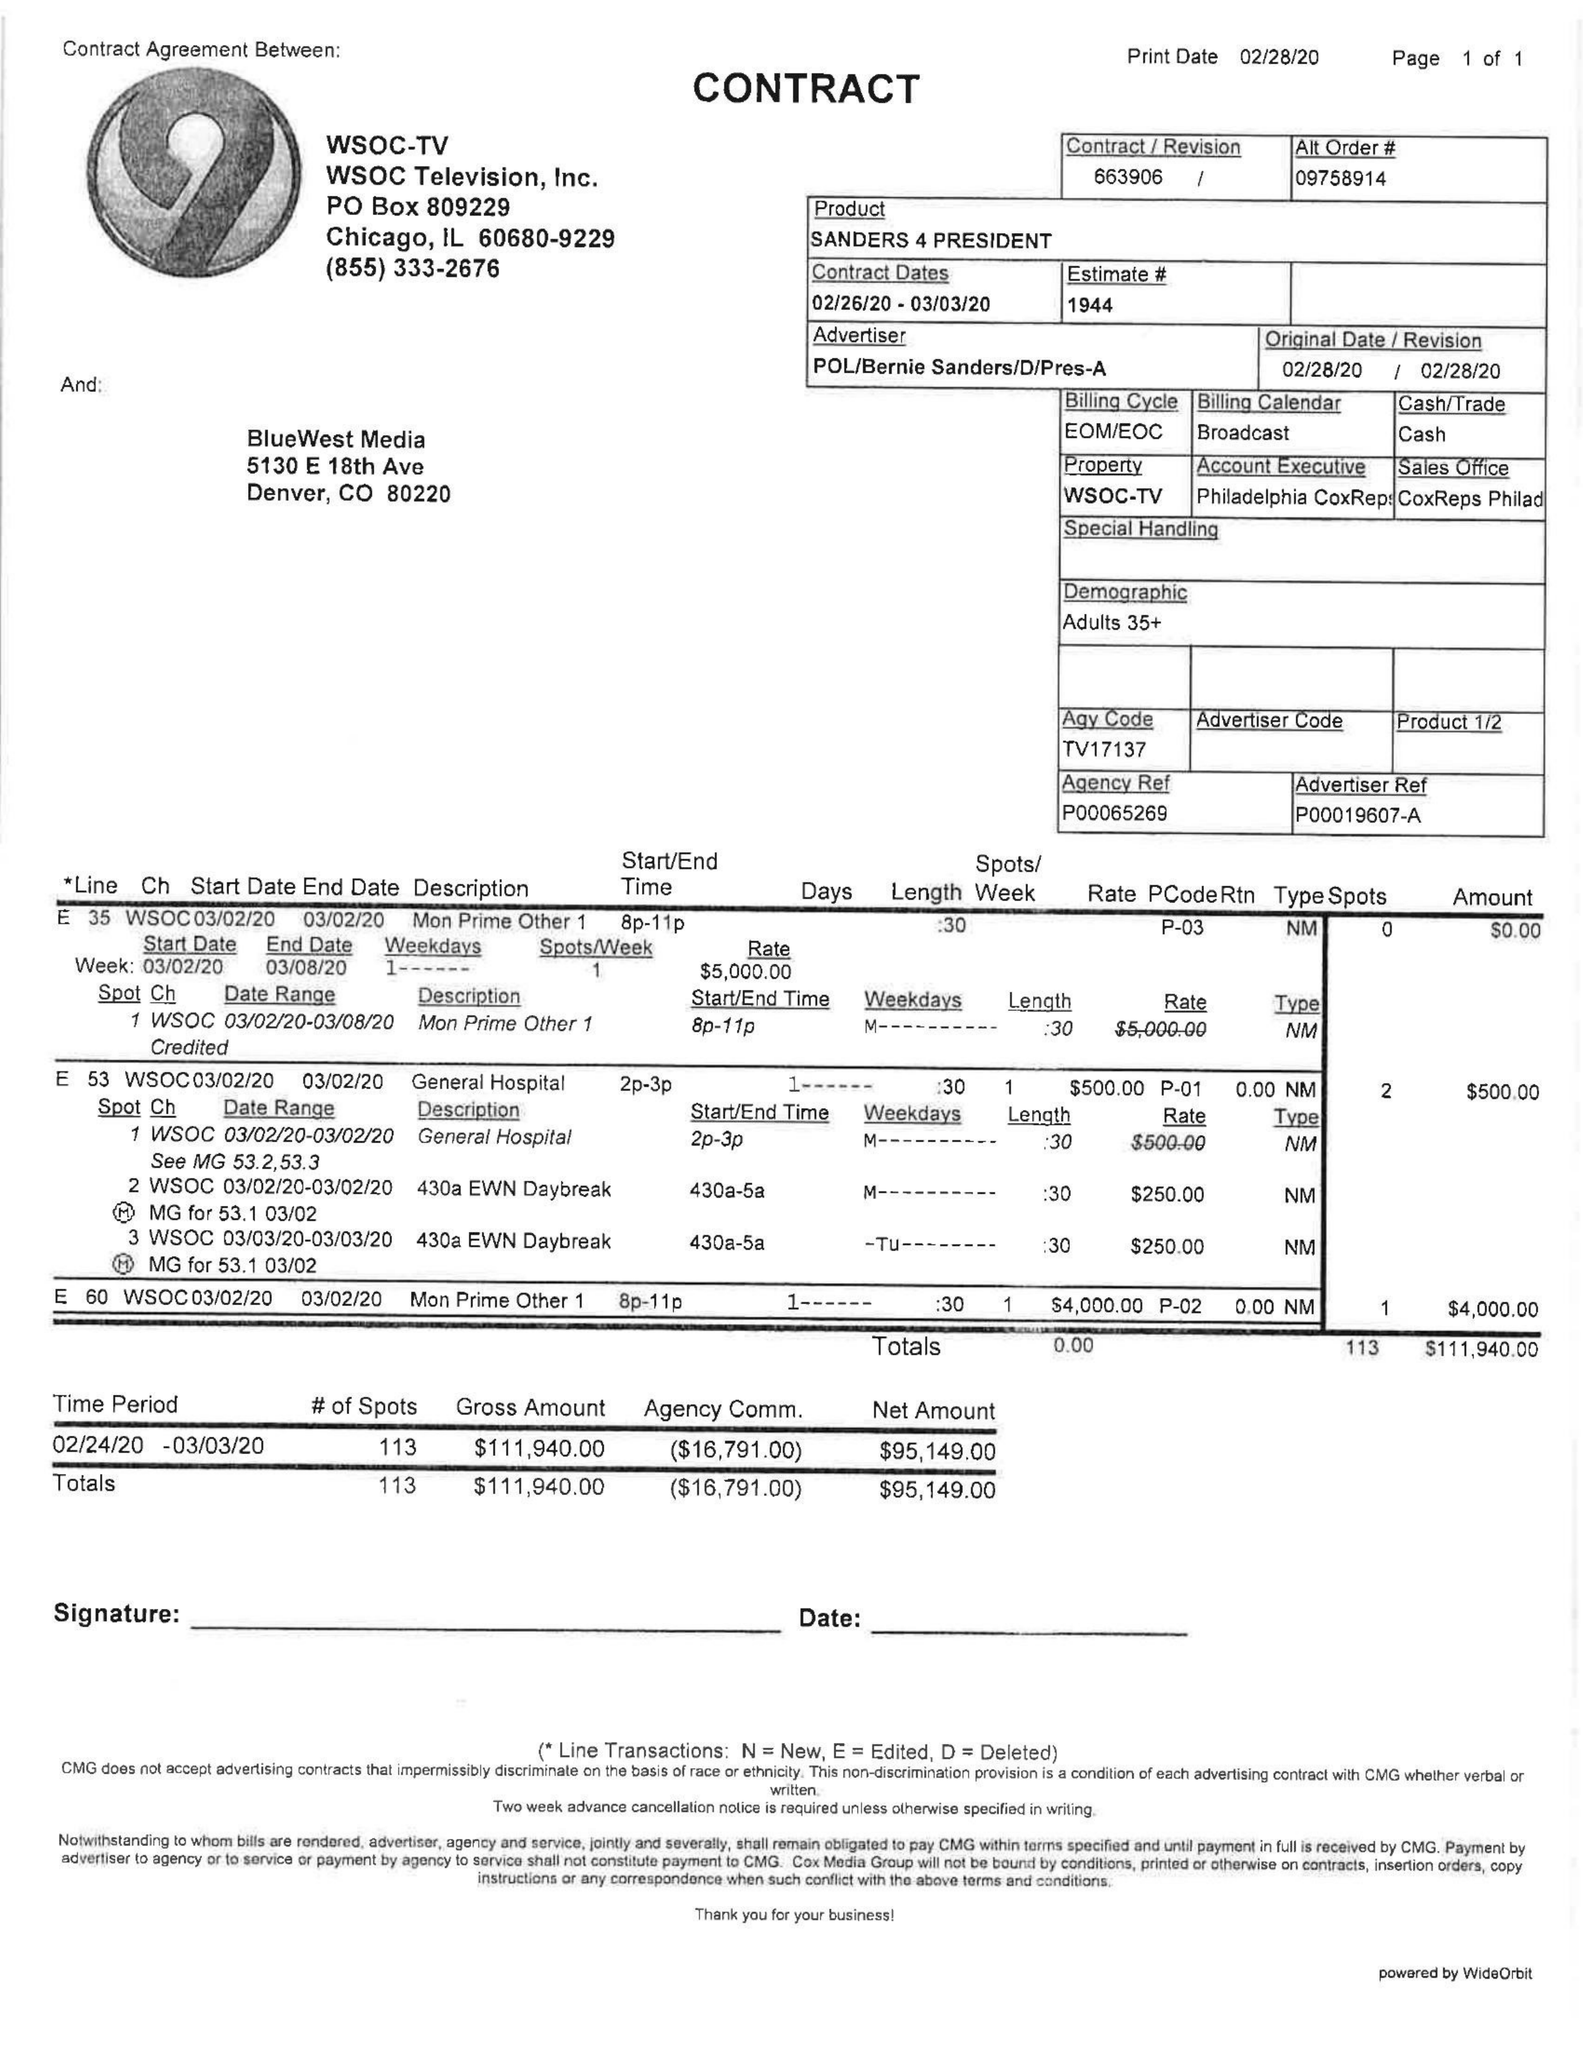What is the value for the advertiser?
Answer the question using a single word or phrase. POL/BERNIESANDERS/D/PRES-A 